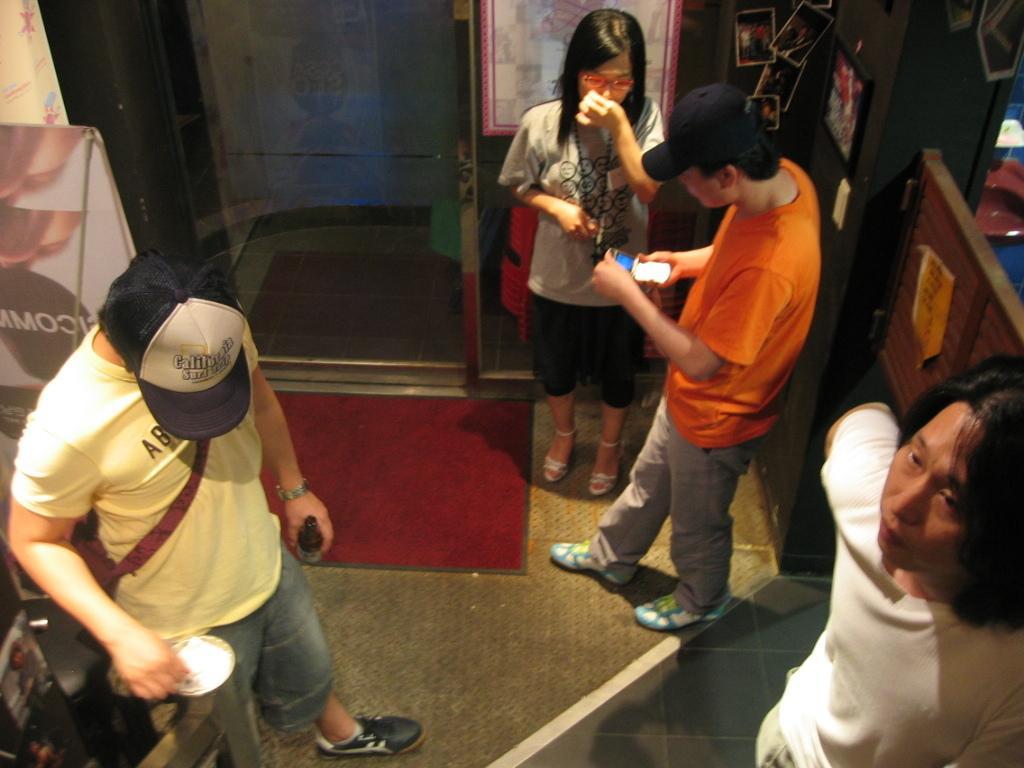Can you describe this image briefly? In the image in the center, we can see a few people are standing and they are holding some objects. In the background there is a wall, glass, board, mat, banners, notes, photo frames, collection of photos and a few other objects. 